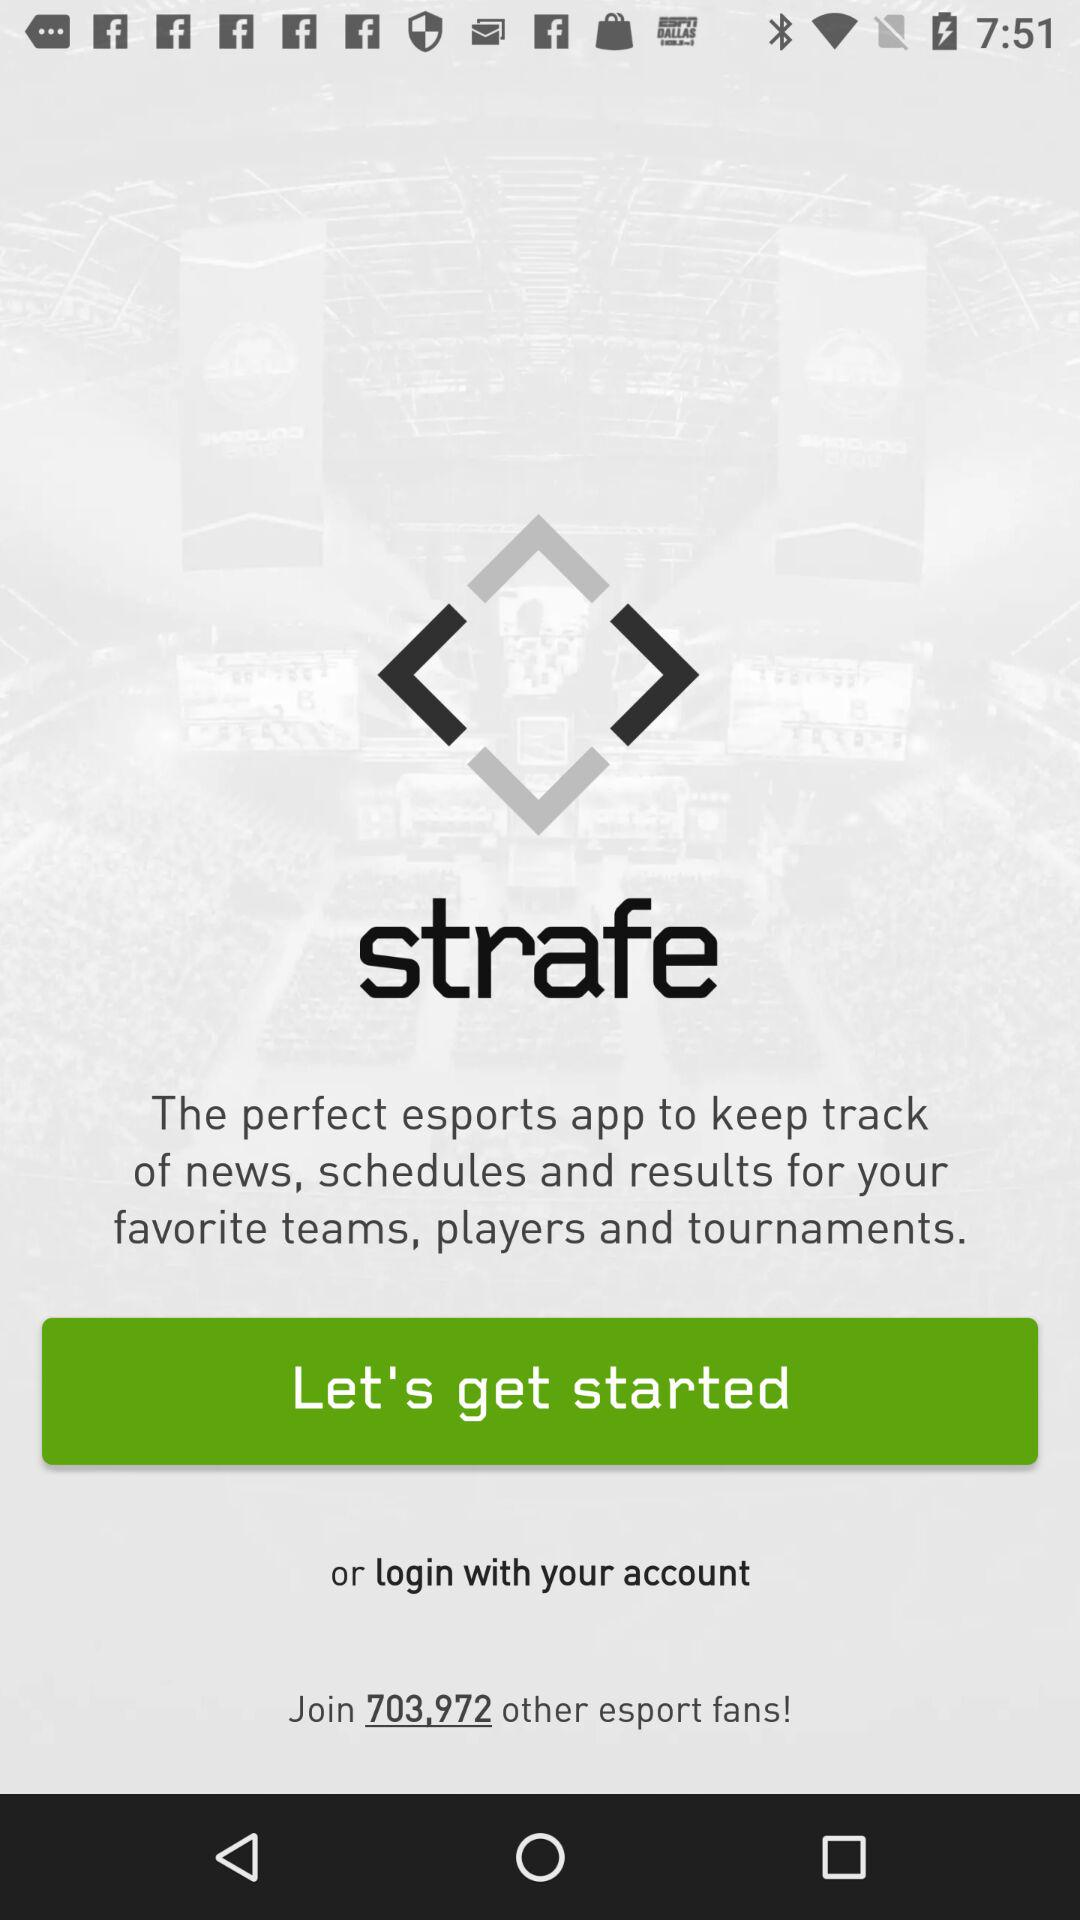How many total esports fans are there? There are 703,972 esports fans. 